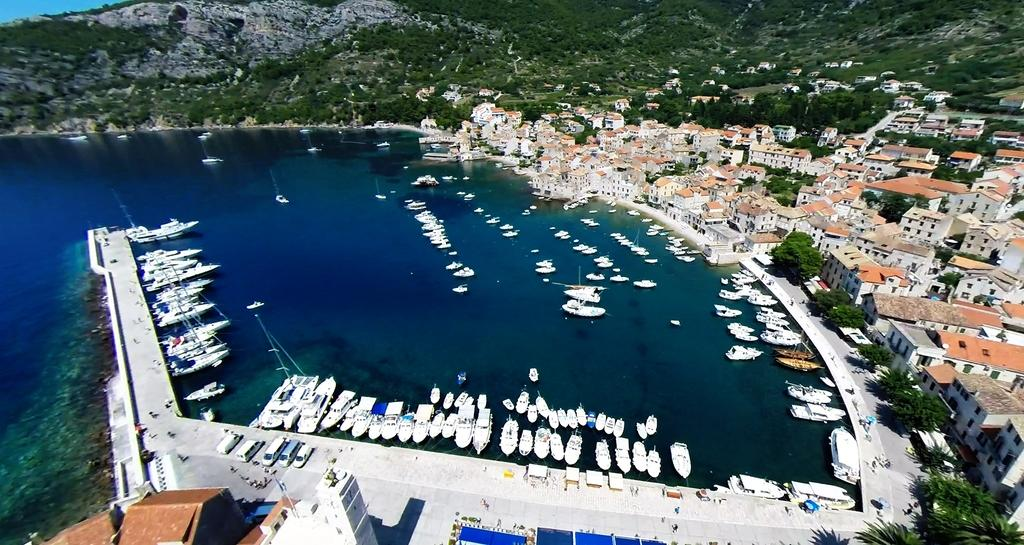What type of view is shown in the image? The image is an aerial view. What structures can be seen in the image? There are buildings in the image. What type of natural elements are present in the image? There are trees and hills in the image. What man-made objects can be seen on the ground in the image? There are vehicles on the road in the image. What water-based vehicles are visible in the image? There are boats and ships in the image. What type of spark can be seen coming from the trees in the image? There is no spark visible in the image, as it features an aerial view of buildings, trees, hills, vehicles, boats, and ships. --- Facts: 1. There is a person holding a camera in the image. 2. The person is standing on a bridge. 3. There is a river below the bridge. 4. There are boats on the river. 5. The sky is visible in the image. Absurd Topics: parrot, sandcastle, umbrella Conversation: What is the person in the image holding? The person in the image is holding a camera. Where is the person standing in the image? The person is standing on a bridge. What can be seen below the bridge in the image? There is a river below the bridge. What type of watercraft is on the river in the image? There are boats on the river. What is visible in the background of the image? The sky is visible in the image. Reasoning: Let's think step by step in order to produce the conversation. We start by identifying the main subject in the image, which is the person holding a camera. Then, we describe the location of the person, which is on a bridge. Next, we mention the river below the bridge and the boats on the river. Finally, we acknowledge the presence of the sky in the background. Absurd Question/Answer: Can you see a parrot sitting on the sandcastle in the image? There is no sandcastle or parrot present in the image; it features a person holding a camera on a bridge with a river, boats, and the sky visible. 